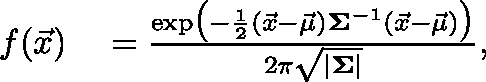Convert formula to latex. <formula><loc_0><loc_0><loc_500><loc_500>\begin{array} { r l } { f ( \vec { x } ) } & = \frac { \exp \, \left ( - \frac { 1 } { 2 } ( \vec { x } - \vec { \mu } ) ^ { \intercal } \Sigma ^ { - 1 } ( \vec { x } - \vec { \mu } ) \right ) } { 2 \pi \sqrt { | \Sigma | } } , } \end{array}</formula> 